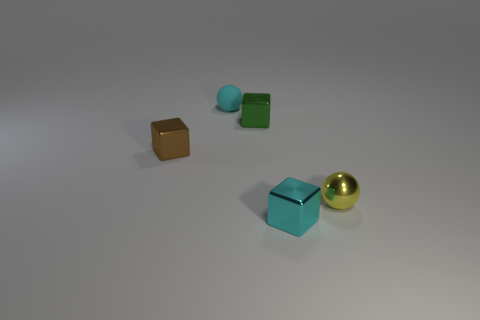Does the sphere behind the small yellow metal thing have the same size as the shiny cube behind the brown shiny object?
Make the answer very short. Yes. The sphere that is made of the same material as the green thing is what color?
Your response must be concise. Yellow. Do the tiny cyan object behind the brown metallic thing and the cyan thing in front of the green metal object have the same material?
Offer a very short reply. No. Are there any green rubber cylinders that have the same size as the green shiny object?
Offer a terse response. No. There is a metal object in front of the small sphere that is on the right side of the matte object; how big is it?
Make the answer very short. Small. How many cubes have the same color as the rubber ball?
Keep it short and to the point. 1. What shape is the tiny metal object that is in front of the sphere on the right side of the small cyan sphere?
Provide a succinct answer. Cube. What number of brown cubes have the same material as the yellow sphere?
Your answer should be very brief. 1. What material is the tiny cyan object that is in front of the small brown object?
Make the answer very short. Metal. The tiny thing that is to the right of the cyan object to the right of the small sphere to the left of the green shiny thing is what shape?
Give a very brief answer. Sphere. 